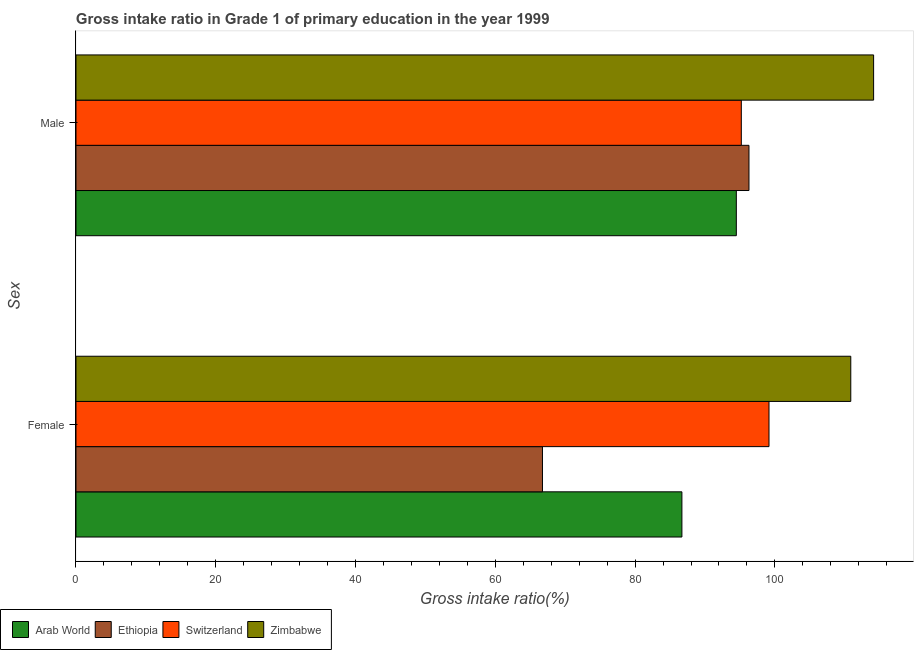Are the number of bars per tick equal to the number of legend labels?
Give a very brief answer. Yes. Are the number of bars on each tick of the Y-axis equal?
Provide a succinct answer. Yes. How many bars are there on the 2nd tick from the top?
Provide a short and direct response. 4. What is the gross intake ratio(male) in Switzerland?
Your answer should be very brief. 95.2. Across all countries, what is the maximum gross intake ratio(male)?
Keep it short and to the point. 114.13. Across all countries, what is the minimum gross intake ratio(male)?
Give a very brief answer. 94.48. In which country was the gross intake ratio(female) maximum?
Ensure brevity in your answer.  Zimbabwe. In which country was the gross intake ratio(female) minimum?
Give a very brief answer. Ethiopia. What is the total gross intake ratio(female) in the graph?
Ensure brevity in your answer.  363.45. What is the difference between the gross intake ratio(male) in Zimbabwe and that in Switzerland?
Your response must be concise. 18.93. What is the difference between the gross intake ratio(female) in Arab World and the gross intake ratio(male) in Switzerland?
Your answer should be compact. -8.5. What is the average gross intake ratio(male) per country?
Your answer should be very brief. 100.02. What is the difference between the gross intake ratio(female) and gross intake ratio(male) in Arab World?
Ensure brevity in your answer.  -7.79. In how many countries, is the gross intake ratio(female) greater than 4 %?
Offer a very short reply. 4. What is the ratio of the gross intake ratio(female) in Zimbabwe to that in Arab World?
Make the answer very short. 1.28. In how many countries, is the gross intake ratio(male) greater than the average gross intake ratio(male) taken over all countries?
Your answer should be very brief. 1. What does the 1st bar from the top in Female represents?
Provide a short and direct response. Zimbabwe. What does the 4th bar from the bottom in Male represents?
Provide a succinct answer. Zimbabwe. How many countries are there in the graph?
Your answer should be very brief. 4. What is the difference between two consecutive major ticks on the X-axis?
Provide a short and direct response. 20. Are the values on the major ticks of X-axis written in scientific E-notation?
Offer a terse response. No. Does the graph contain grids?
Make the answer very short. No. Where does the legend appear in the graph?
Give a very brief answer. Bottom left. How many legend labels are there?
Your answer should be very brief. 4. How are the legend labels stacked?
Offer a very short reply. Horizontal. What is the title of the graph?
Make the answer very short. Gross intake ratio in Grade 1 of primary education in the year 1999. What is the label or title of the X-axis?
Ensure brevity in your answer.  Gross intake ratio(%). What is the label or title of the Y-axis?
Offer a very short reply. Sex. What is the Gross intake ratio(%) of Arab World in Female?
Offer a very short reply. 86.7. What is the Gross intake ratio(%) of Ethiopia in Female?
Make the answer very short. 66.74. What is the Gross intake ratio(%) of Switzerland in Female?
Your answer should be very brief. 99.16. What is the Gross intake ratio(%) in Zimbabwe in Female?
Provide a succinct answer. 110.86. What is the Gross intake ratio(%) in Arab World in Male?
Ensure brevity in your answer.  94.48. What is the Gross intake ratio(%) in Ethiopia in Male?
Your response must be concise. 96.29. What is the Gross intake ratio(%) in Switzerland in Male?
Keep it short and to the point. 95.2. What is the Gross intake ratio(%) of Zimbabwe in Male?
Give a very brief answer. 114.13. Across all Sex, what is the maximum Gross intake ratio(%) of Arab World?
Give a very brief answer. 94.48. Across all Sex, what is the maximum Gross intake ratio(%) in Ethiopia?
Give a very brief answer. 96.29. Across all Sex, what is the maximum Gross intake ratio(%) in Switzerland?
Give a very brief answer. 99.16. Across all Sex, what is the maximum Gross intake ratio(%) of Zimbabwe?
Provide a short and direct response. 114.13. Across all Sex, what is the minimum Gross intake ratio(%) of Arab World?
Ensure brevity in your answer.  86.7. Across all Sex, what is the minimum Gross intake ratio(%) in Ethiopia?
Ensure brevity in your answer.  66.74. Across all Sex, what is the minimum Gross intake ratio(%) in Switzerland?
Keep it short and to the point. 95.2. Across all Sex, what is the minimum Gross intake ratio(%) in Zimbabwe?
Your response must be concise. 110.86. What is the total Gross intake ratio(%) of Arab World in the graph?
Give a very brief answer. 181.18. What is the total Gross intake ratio(%) of Ethiopia in the graph?
Offer a terse response. 163.03. What is the total Gross intake ratio(%) of Switzerland in the graph?
Offer a terse response. 194.35. What is the total Gross intake ratio(%) of Zimbabwe in the graph?
Make the answer very short. 224.98. What is the difference between the Gross intake ratio(%) in Arab World in Female and that in Male?
Offer a very short reply. -7.79. What is the difference between the Gross intake ratio(%) in Ethiopia in Female and that in Male?
Provide a short and direct response. -29.55. What is the difference between the Gross intake ratio(%) of Switzerland in Female and that in Male?
Offer a very short reply. 3.96. What is the difference between the Gross intake ratio(%) of Zimbabwe in Female and that in Male?
Offer a very short reply. -3.27. What is the difference between the Gross intake ratio(%) in Arab World in Female and the Gross intake ratio(%) in Ethiopia in Male?
Offer a terse response. -9.6. What is the difference between the Gross intake ratio(%) in Arab World in Female and the Gross intake ratio(%) in Switzerland in Male?
Make the answer very short. -8.5. What is the difference between the Gross intake ratio(%) in Arab World in Female and the Gross intake ratio(%) in Zimbabwe in Male?
Make the answer very short. -27.43. What is the difference between the Gross intake ratio(%) in Ethiopia in Female and the Gross intake ratio(%) in Switzerland in Male?
Give a very brief answer. -28.45. What is the difference between the Gross intake ratio(%) of Ethiopia in Female and the Gross intake ratio(%) of Zimbabwe in Male?
Keep it short and to the point. -47.38. What is the difference between the Gross intake ratio(%) of Switzerland in Female and the Gross intake ratio(%) of Zimbabwe in Male?
Your response must be concise. -14.97. What is the average Gross intake ratio(%) in Arab World per Sex?
Keep it short and to the point. 90.59. What is the average Gross intake ratio(%) of Ethiopia per Sex?
Your answer should be compact. 81.52. What is the average Gross intake ratio(%) of Switzerland per Sex?
Your answer should be compact. 97.18. What is the average Gross intake ratio(%) of Zimbabwe per Sex?
Keep it short and to the point. 112.49. What is the difference between the Gross intake ratio(%) of Arab World and Gross intake ratio(%) of Ethiopia in Female?
Your answer should be compact. 19.95. What is the difference between the Gross intake ratio(%) in Arab World and Gross intake ratio(%) in Switzerland in Female?
Keep it short and to the point. -12.46. What is the difference between the Gross intake ratio(%) in Arab World and Gross intake ratio(%) in Zimbabwe in Female?
Your answer should be compact. -24.16. What is the difference between the Gross intake ratio(%) of Ethiopia and Gross intake ratio(%) of Switzerland in Female?
Keep it short and to the point. -32.41. What is the difference between the Gross intake ratio(%) in Ethiopia and Gross intake ratio(%) in Zimbabwe in Female?
Make the answer very short. -44.11. What is the difference between the Gross intake ratio(%) in Switzerland and Gross intake ratio(%) in Zimbabwe in Female?
Ensure brevity in your answer.  -11.7. What is the difference between the Gross intake ratio(%) of Arab World and Gross intake ratio(%) of Ethiopia in Male?
Your response must be concise. -1.81. What is the difference between the Gross intake ratio(%) of Arab World and Gross intake ratio(%) of Switzerland in Male?
Provide a succinct answer. -0.71. What is the difference between the Gross intake ratio(%) of Arab World and Gross intake ratio(%) of Zimbabwe in Male?
Give a very brief answer. -19.64. What is the difference between the Gross intake ratio(%) of Ethiopia and Gross intake ratio(%) of Switzerland in Male?
Offer a very short reply. 1.09. What is the difference between the Gross intake ratio(%) in Ethiopia and Gross intake ratio(%) in Zimbabwe in Male?
Keep it short and to the point. -17.84. What is the difference between the Gross intake ratio(%) of Switzerland and Gross intake ratio(%) of Zimbabwe in Male?
Give a very brief answer. -18.93. What is the ratio of the Gross intake ratio(%) in Arab World in Female to that in Male?
Your answer should be compact. 0.92. What is the ratio of the Gross intake ratio(%) of Ethiopia in Female to that in Male?
Provide a short and direct response. 0.69. What is the ratio of the Gross intake ratio(%) of Switzerland in Female to that in Male?
Give a very brief answer. 1.04. What is the ratio of the Gross intake ratio(%) in Zimbabwe in Female to that in Male?
Ensure brevity in your answer.  0.97. What is the difference between the highest and the second highest Gross intake ratio(%) in Arab World?
Provide a short and direct response. 7.79. What is the difference between the highest and the second highest Gross intake ratio(%) in Ethiopia?
Provide a succinct answer. 29.55. What is the difference between the highest and the second highest Gross intake ratio(%) in Switzerland?
Offer a very short reply. 3.96. What is the difference between the highest and the second highest Gross intake ratio(%) in Zimbabwe?
Keep it short and to the point. 3.27. What is the difference between the highest and the lowest Gross intake ratio(%) in Arab World?
Give a very brief answer. 7.79. What is the difference between the highest and the lowest Gross intake ratio(%) of Ethiopia?
Give a very brief answer. 29.55. What is the difference between the highest and the lowest Gross intake ratio(%) of Switzerland?
Your answer should be very brief. 3.96. What is the difference between the highest and the lowest Gross intake ratio(%) in Zimbabwe?
Offer a terse response. 3.27. 